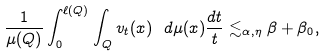Convert formula to latex. <formula><loc_0><loc_0><loc_500><loc_500>\frac { 1 } { \mu ( Q ) } \int _ { 0 } ^ { \ell ( Q ) } \int _ { Q } v _ { t } ( x ) \ d \mu ( x ) \frac { d t } { t } \lesssim _ { \alpha , \eta } \beta + \beta _ { 0 } ,</formula> 